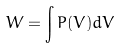Convert formula to latex. <formula><loc_0><loc_0><loc_500><loc_500>W = \int P ( V ) d V</formula> 